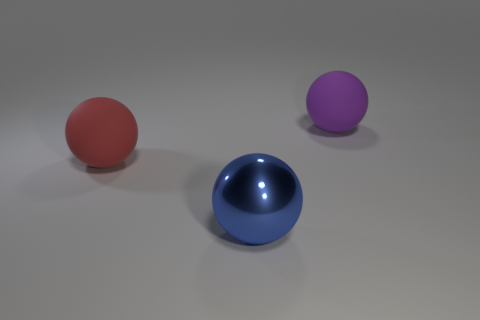Add 1 yellow rubber cylinders. How many objects exist? 4 Subtract all red matte spheres. How many spheres are left? 2 Subtract all cyan balls. Subtract all gray cubes. How many balls are left? 3 Subtract all purple blocks. How many purple spheres are left? 1 Subtract all purple spheres. Subtract all blue metallic things. How many objects are left? 1 Add 2 large red rubber things. How many large red rubber things are left? 3 Add 1 big cyan cylinders. How many big cyan cylinders exist? 1 Subtract 0 purple cylinders. How many objects are left? 3 